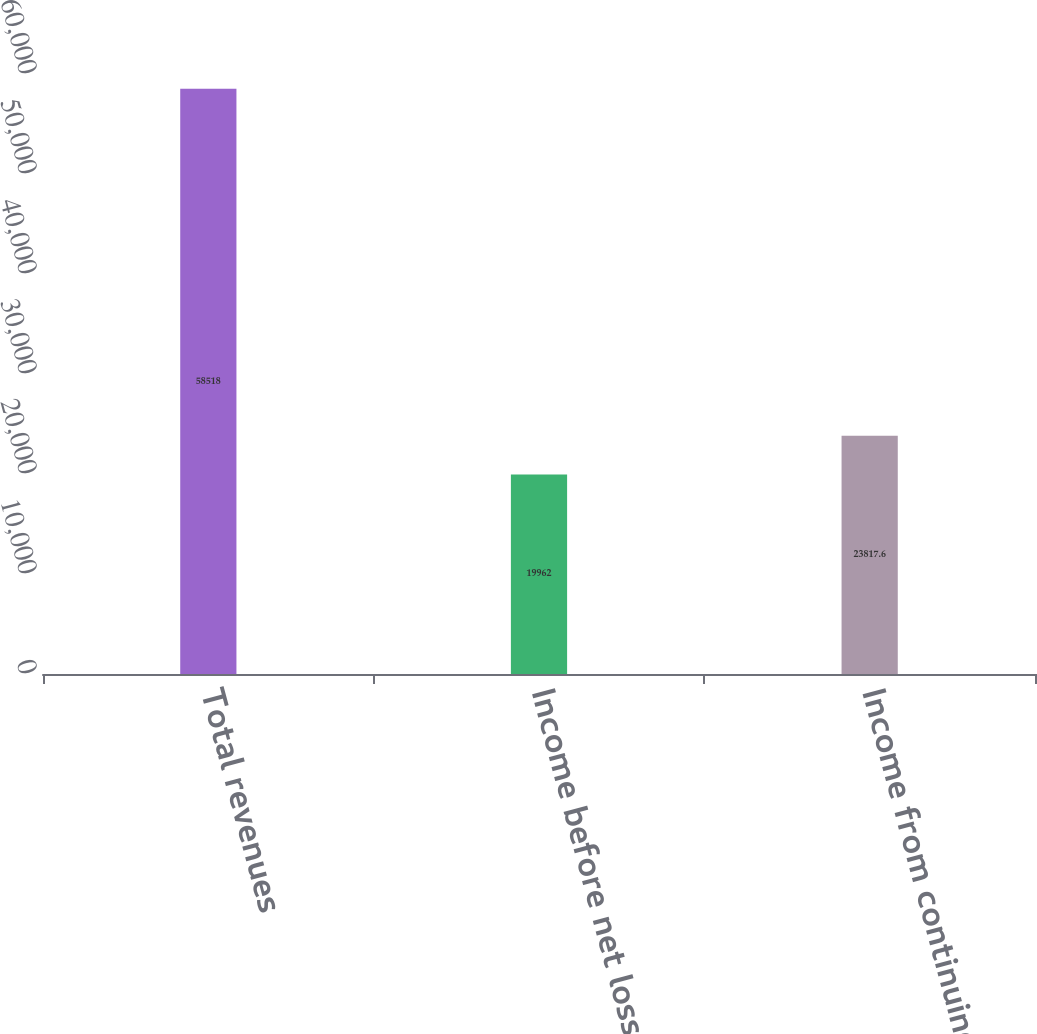Convert chart to OTSL. <chart><loc_0><loc_0><loc_500><loc_500><bar_chart><fcel>Total revenues<fcel>Income before net loss on real<fcel>Income from continuing<nl><fcel>58518<fcel>19962<fcel>23817.6<nl></chart> 